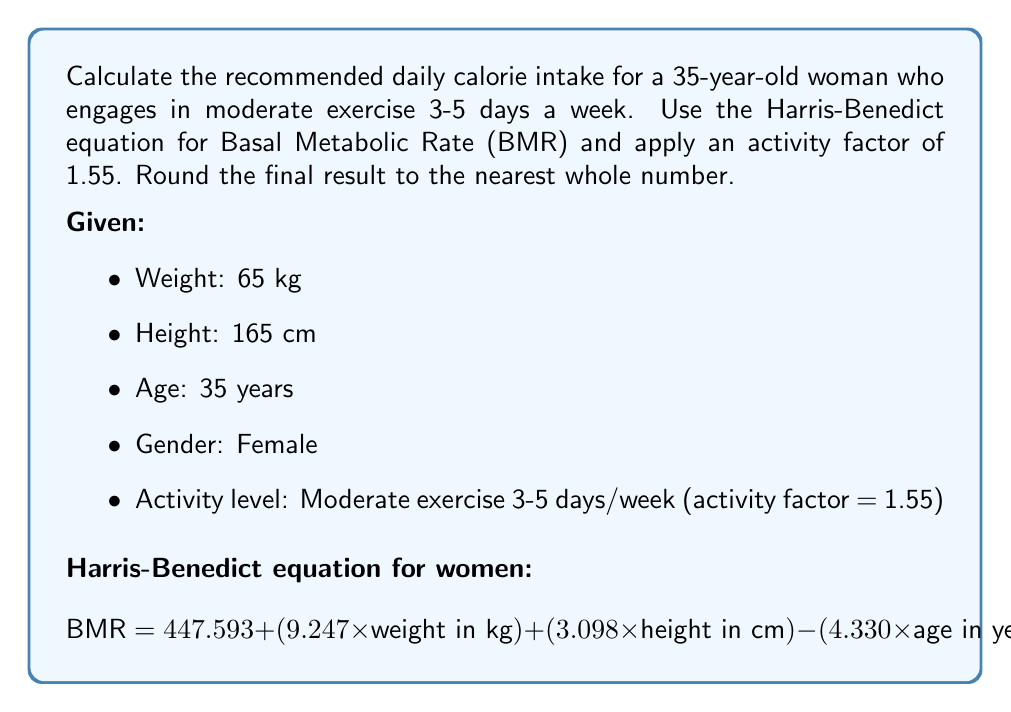Solve this math problem. To calculate the recommended daily calorie intake, we'll follow these steps:

1. Calculate the Basal Metabolic Rate (BMR) using the Harris-Benedict equation for women:

$$ BMR = 447.593 + (9.247 \times 65) + (3.098 \times 165) - (4.330 \times 35) $$

$$ BMR = 447.593 + 601.055 + 511.170 - 151.550 $$

$$ BMR = 1408.268 \text{ calories} $$

2. Apply the activity factor to the BMR to get the recommended daily calorie intake:

$$ \text{Daily Calorie Intake} = BMR \times \text{Activity Factor} $$

$$ \text{Daily Calorie Intake} = 1408.268 \times 1.55 $$

$$ \text{Daily Calorie Intake} = 2182.8154 \text{ calories} $$

3. Round the result to the nearest whole number:

$$ \text{Recommended Daily Calorie Intake} = 2183 \text{ calories} $$
Answer: 2183 calories 